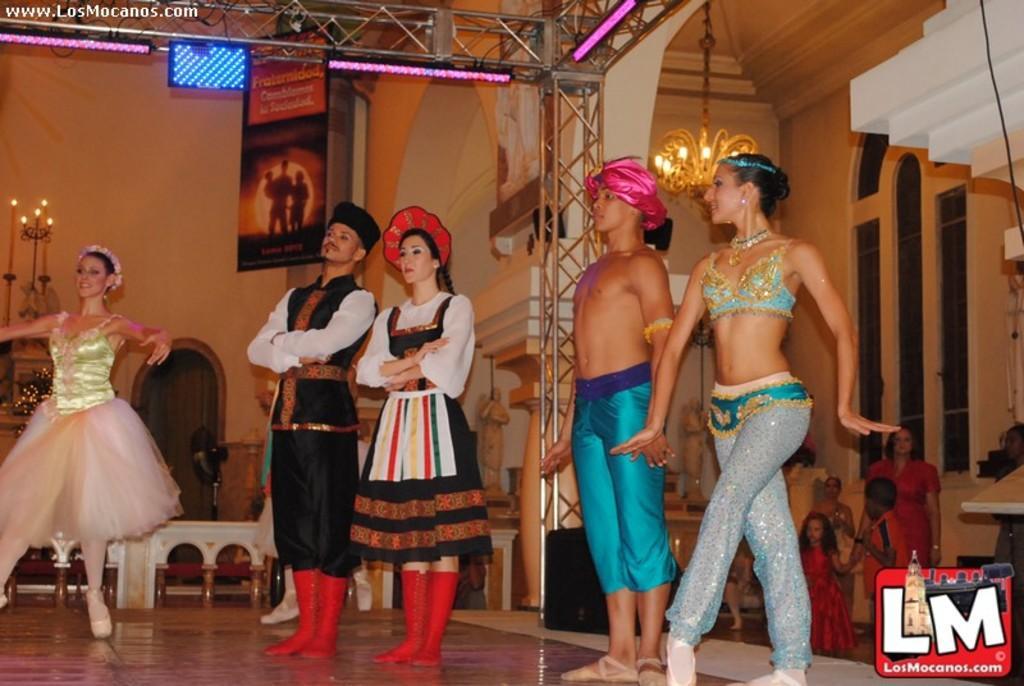Could you give a brief overview of what you see in this image? At the top we can see the lights. In this picture we can see the beams, a frame on the wall, candles placed on the stands. We can see the people wearing different costumes and standing on the platform. On the right side of the picture we can see the windows, few people and the wall. We can see a table fan and few objects. On the right side of the picture we can see the watermark and a black wire. 